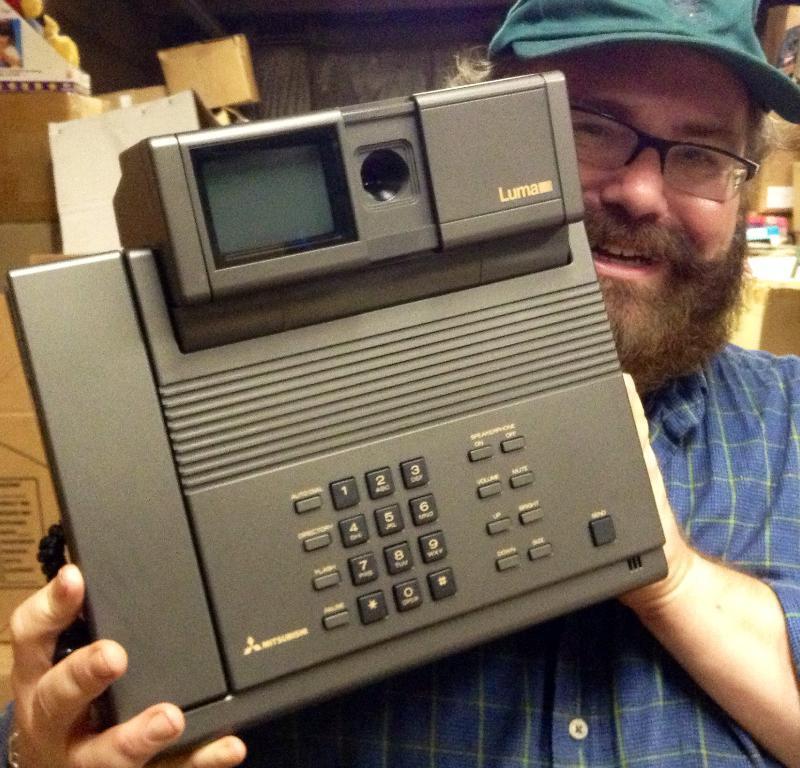Could you give a brief overview of what you see in this image? in this picture there is a man holding a telephone. In the background there are boxes and wall. 